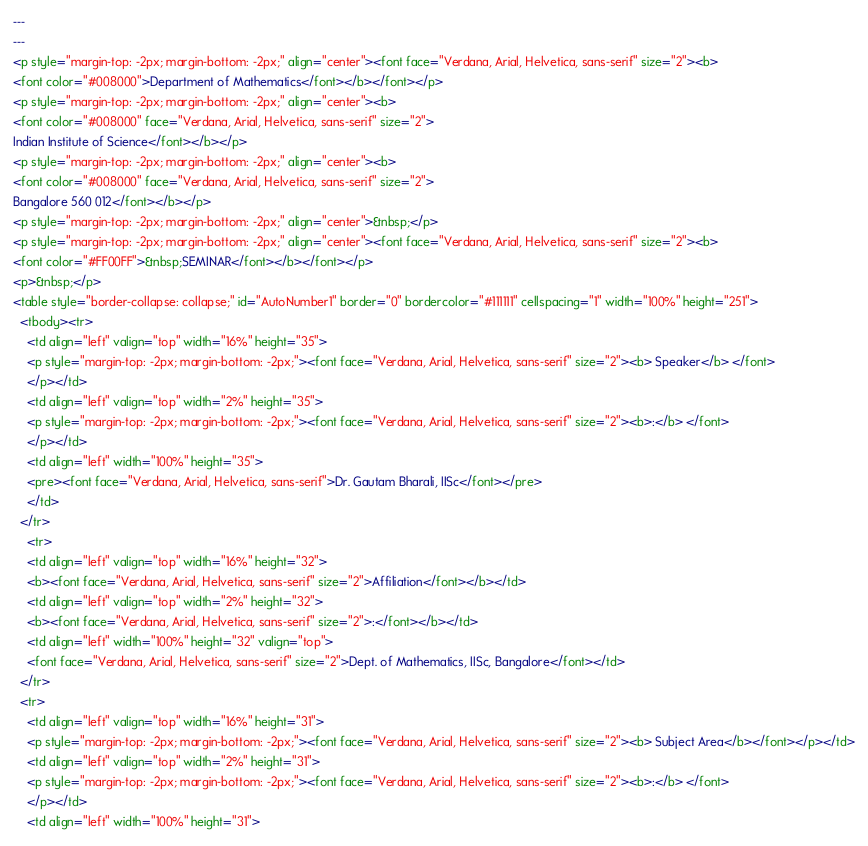<code> <loc_0><loc_0><loc_500><loc_500><_HTML_>---
---
<p style="margin-top: -2px; margin-bottom: -2px;" align="center"><font face="Verdana, Arial, Helvetica, sans-serif" size="2"><b>
<font color="#008000">Department of Mathematics</font></b></font></p>
<p style="margin-top: -2px; margin-bottom: -2px;" align="center"><b>
<font color="#008000" face="Verdana, Arial, Helvetica, sans-serif" size="2">
Indian Institute of Science</font></b></p>
<p style="margin-top: -2px; margin-bottom: -2px;" align="center"><b>
<font color="#008000" face="Verdana, Arial, Helvetica, sans-serif" size="2">
Bangalore 560 012</font></b></p>
<p style="margin-top: -2px; margin-bottom: -2px;" align="center">&nbsp;</p>
<p style="margin-top: -2px; margin-bottom: -2px;" align="center"><font face="Verdana, Arial, Helvetica, sans-serif" size="2"><b>
<font color="#FF00FF">&nbsp;SEMINAR</font></b></font></p>
<p>&nbsp;</p>
<table style="border-collapse: collapse;" id="AutoNumber1" border="0" bordercolor="#111111" cellspacing="1" width="100%" height="251">
  <tbody><tr>
    <td align="left" valign="top" width="16%" height="35">
    <p style="margin-top: -2px; margin-bottom: -2px;"><font face="Verdana, Arial, Helvetica, sans-serif" size="2"><b> Speaker</b> </font>
    </p></td>
    <td align="left" valign="top" width="2%" height="35">
    <p style="margin-top: -2px; margin-bottom: -2px;"><font face="Verdana, Arial, Helvetica, sans-serif" size="2"><b>:</b> </font>
    </p></td>
    <td align="left" width="100%" height="35">
    <pre><font face="Verdana, Arial, Helvetica, sans-serif">Dr. Gautam Bharali, IISc</font></pre>
    </td>
  </tr>
    <tr>
    <td align="left" valign="top" width="16%" height="32">
    <b><font face="Verdana, Arial, Helvetica, sans-serif" size="2">Affiliation</font></b></td>
    <td align="left" valign="top" width="2%" height="32">
    <b><font face="Verdana, Arial, Helvetica, sans-serif" size="2">:</font></b></td>
    <td align="left" width="100%" height="32" valign="top">
    <font face="Verdana, Arial, Helvetica, sans-serif" size="2">Dept. of Mathematics, IISc, Bangalore</font></td>
  </tr>
  <tr>
    <td align="left" valign="top" width="16%" height="31">
    <p style="margin-top: -2px; margin-bottom: -2px;"><font face="Verdana, Arial, Helvetica, sans-serif" size="2"><b> Subject Area</b></font></p></td>
    <td align="left" valign="top" width="2%" height="31">
    <p style="margin-top: -2px; margin-bottom: -2px;"><font face="Verdana, Arial, Helvetica, sans-serif" size="2"><b>:</b> </font>
    </p></td>
    <td align="left" width="100%" height="31"></code> 